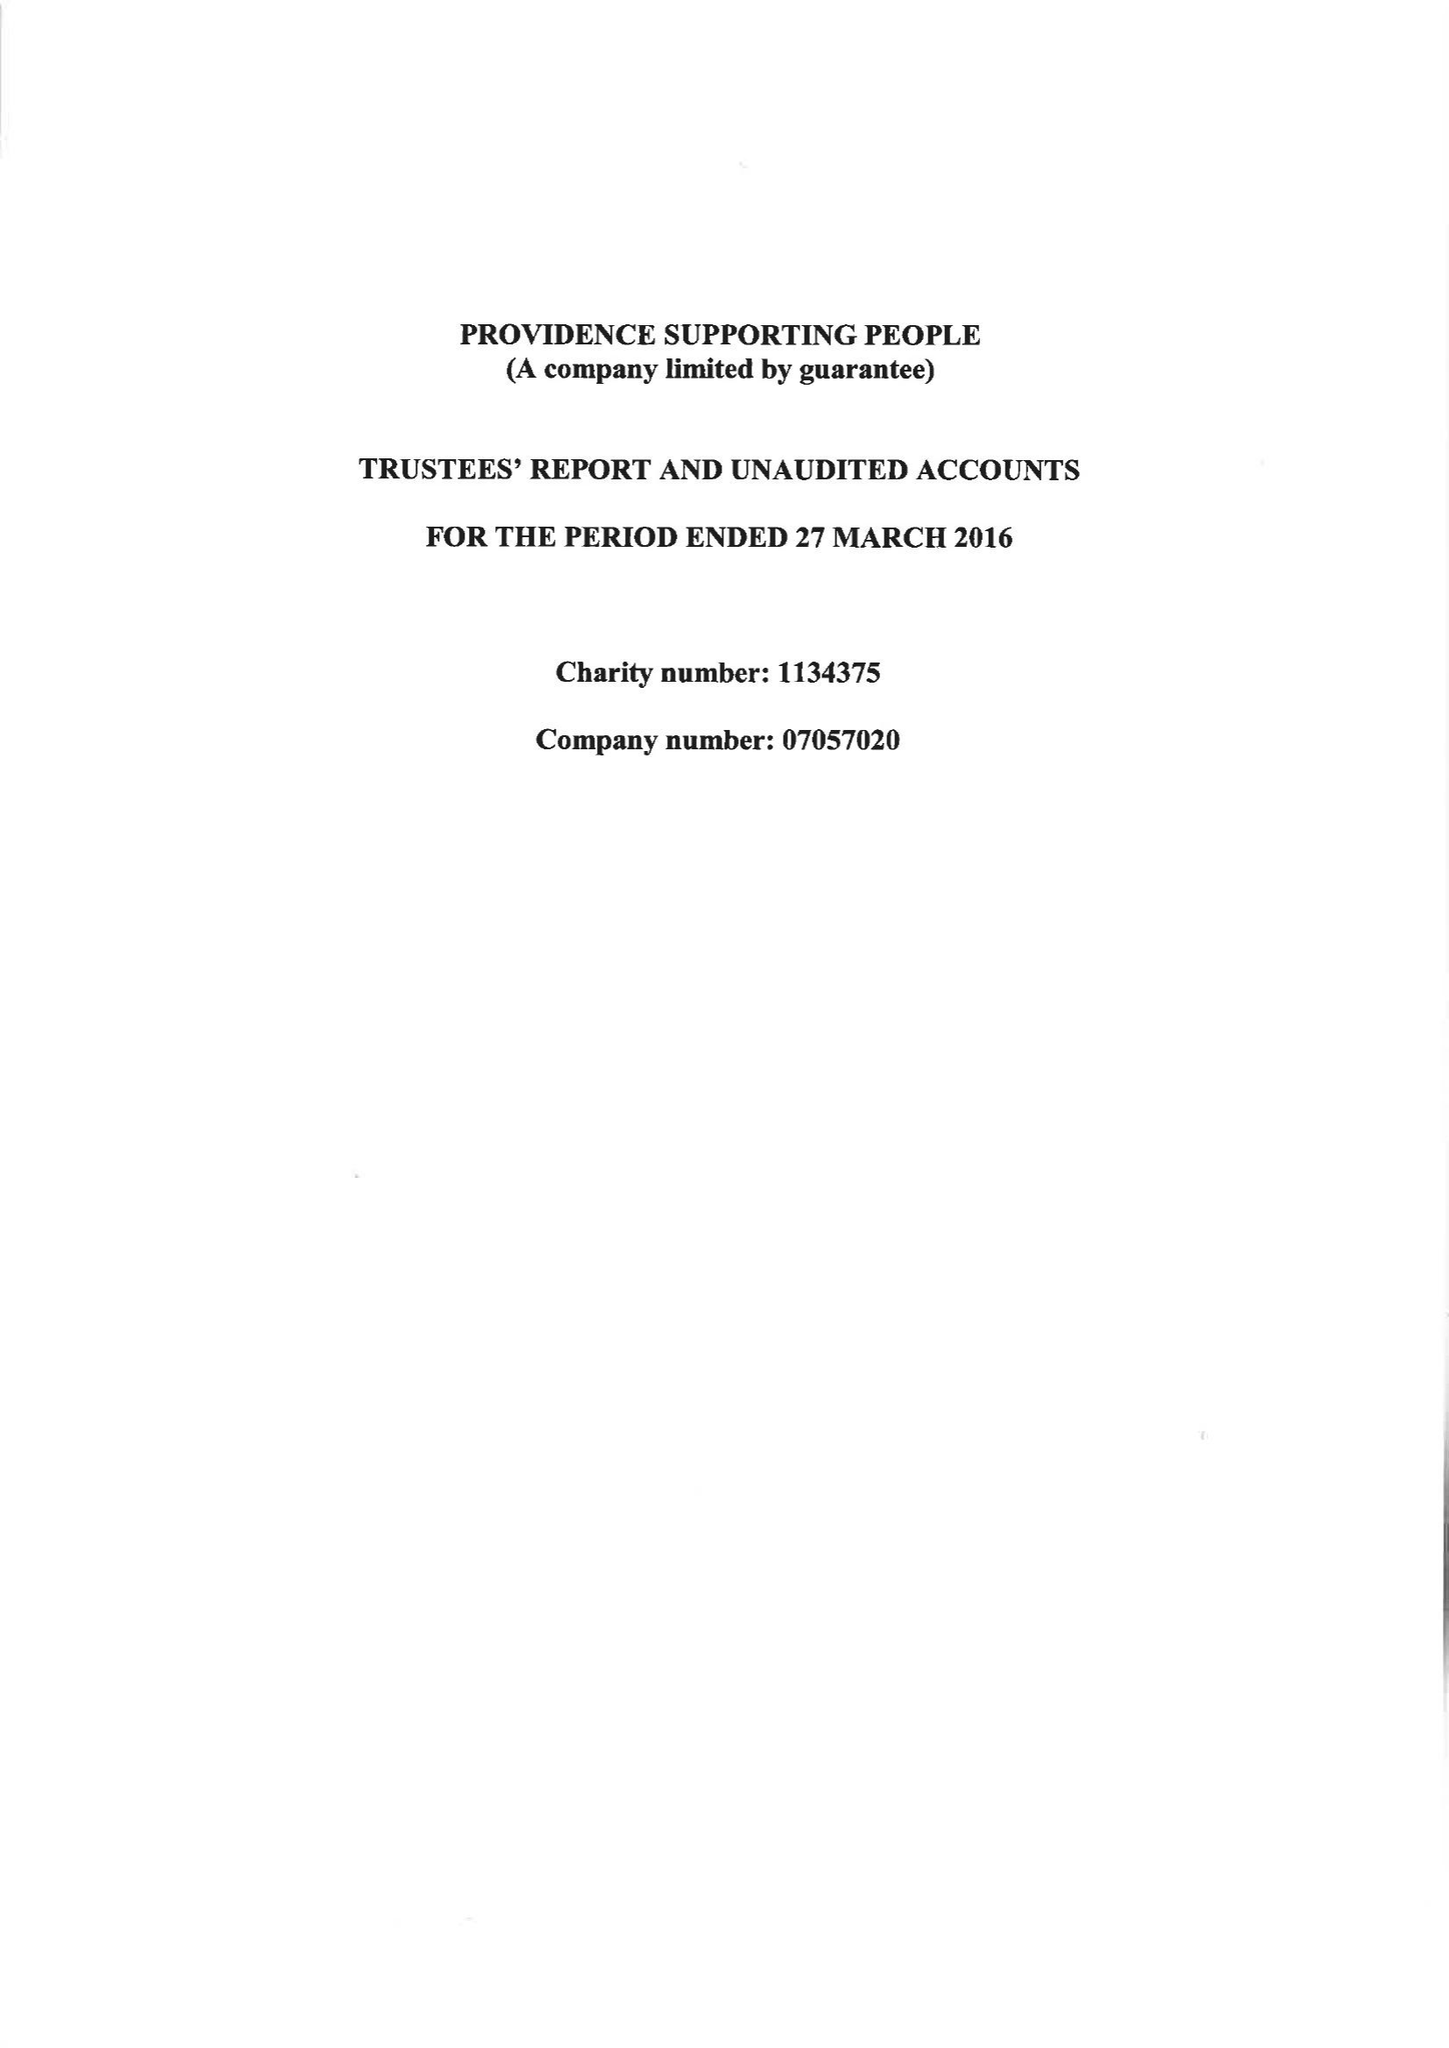What is the value for the income_annually_in_british_pounds?
Answer the question using a single word or phrase. 265166.00 